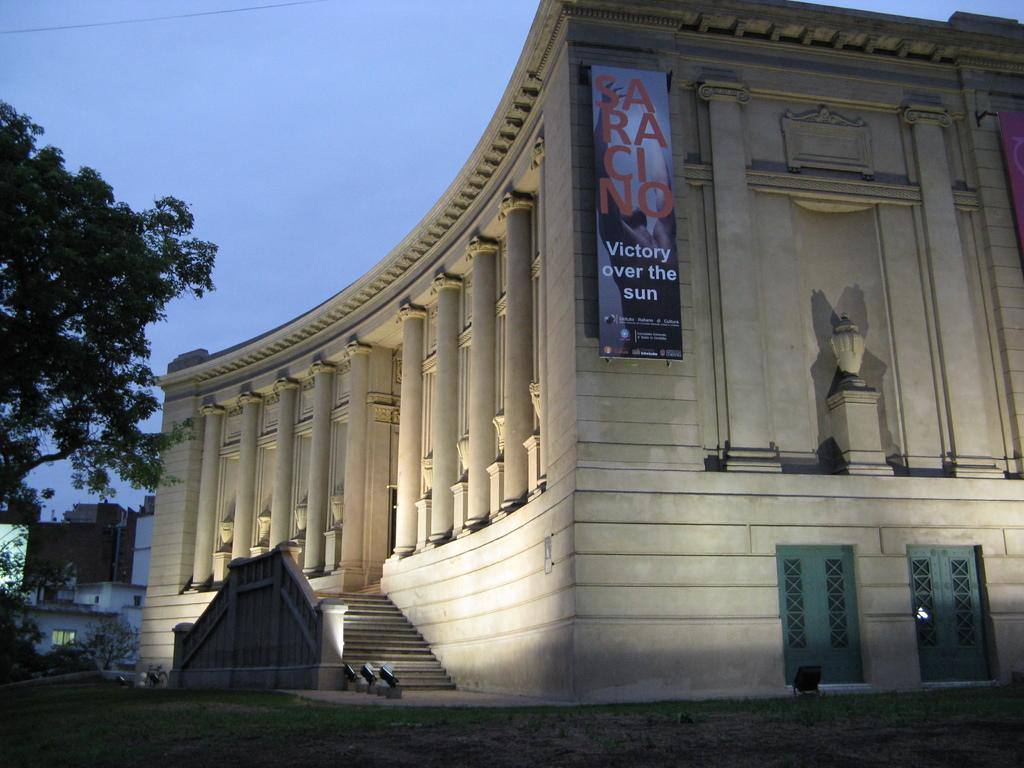What type of structures can be seen in the image? There are buildings in the image. What architectural feature is present in the image? There are stairs in the image. What object is present in the image that might be used for displaying information? There is a board in the image. What type of vegetation is visible in the image? There are trees in the image. What type of entrance or exit can be seen in the image? There are doors in the image. What part of the natural environment is visible in the image? The sky is visible at the top of the image. What type of pathway is visible at the bottom of the image? There is a road visible at the bottom of the image. What type of flame can be seen burning on the board in the image? There is no flame present on the board in the image. What answer can be found on the board in the image? The board in the image does not contain any answers, as it is not a question or test. 